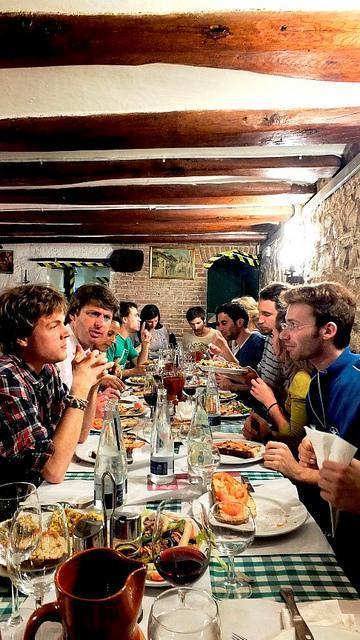How many people are there?
Give a very brief answer. 5. How many cups are in the photo?
Give a very brief answer. 3. How many bottles are in the photo?
Give a very brief answer. 2. How many wine glasses are there?
Give a very brief answer. 5. 